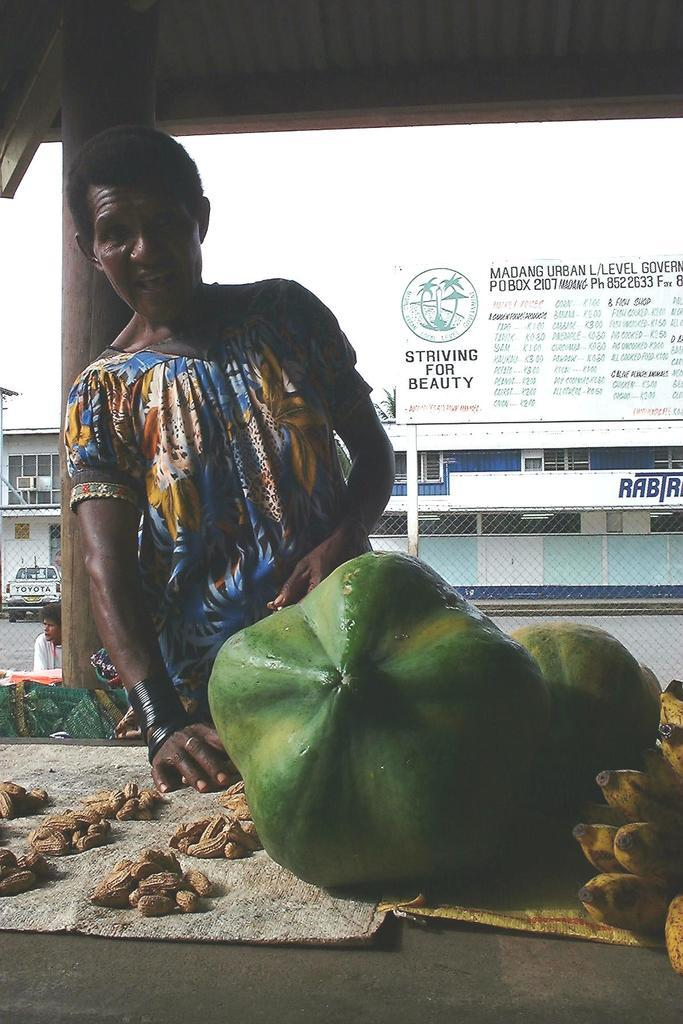What is the position of the person in relation to the table in the image? There is a person in front of the table in the image. What items can be seen on the table? The table has fruits and nuts on it. Can you describe the position of the other person in the image? There is another person behind the table in the image. What type of barrier is visible in the image? There is fencing visible in the image. What else can be seen in the image besides the people and table? Vehicles are present in the image, and there are buildings in the background. What type of advice is the goat giving to the person behind the table in the image? There is no goat present in the image, so it is not possible to answer that question. 